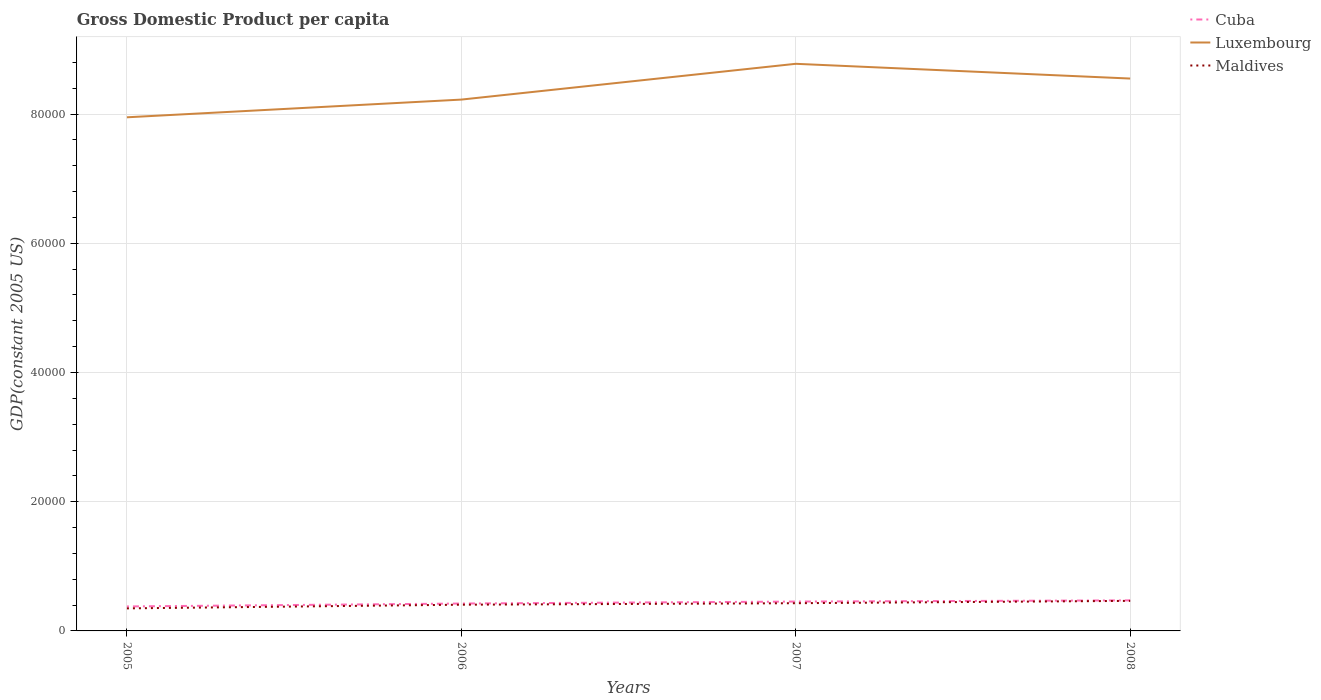How many different coloured lines are there?
Your answer should be very brief. 3. Across all years, what is the maximum GDP per capita in Luxembourg?
Your answer should be very brief. 7.95e+04. In which year was the GDP per capita in Cuba maximum?
Offer a very short reply. 2005. What is the total GDP per capita in Luxembourg in the graph?
Provide a succinct answer. 2281.91. What is the difference between the highest and the second highest GDP per capita in Cuba?
Ensure brevity in your answer.  940.25. What is the difference between the highest and the lowest GDP per capita in Cuba?
Your answer should be compact. 2. Is the GDP per capita in Cuba strictly greater than the GDP per capita in Maldives over the years?
Keep it short and to the point. No. What is the difference between two consecutive major ticks on the Y-axis?
Your answer should be compact. 2.00e+04. Are the values on the major ticks of Y-axis written in scientific E-notation?
Your answer should be very brief. No. Does the graph contain any zero values?
Ensure brevity in your answer.  No. How many legend labels are there?
Your response must be concise. 3. What is the title of the graph?
Keep it short and to the point. Gross Domestic Product per capita. Does "Singapore" appear as one of the legend labels in the graph?
Your answer should be very brief. No. What is the label or title of the X-axis?
Make the answer very short. Years. What is the label or title of the Y-axis?
Provide a succinct answer. GDP(constant 2005 US). What is the GDP(constant 2005 US) of Cuba in 2005?
Keep it short and to the point. 3786.88. What is the GDP(constant 2005 US) in Luxembourg in 2005?
Offer a very short reply. 7.95e+04. What is the GDP(constant 2005 US) of Maldives in 2005?
Ensure brevity in your answer.  3488.49. What is the GDP(constant 2005 US) of Cuba in 2006?
Ensure brevity in your answer.  4238.47. What is the GDP(constant 2005 US) of Luxembourg in 2006?
Offer a terse response. 8.22e+04. What is the GDP(constant 2005 US) of Maldives in 2006?
Offer a very short reply. 4057.34. What is the GDP(constant 2005 US) in Cuba in 2007?
Your response must be concise. 4542.71. What is the GDP(constant 2005 US) in Luxembourg in 2007?
Keep it short and to the point. 8.78e+04. What is the GDP(constant 2005 US) in Maldives in 2007?
Offer a very short reply. 4289.08. What is the GDP(constant 2005 US) of Cuba in 2008?
Offer a terse response. 4727.13. What is the GDP(constant 2005 US) of Luxembourg in 2008?
Your response must be concise. 8.55e+04. What is the GDP(constant 2005 US) in Maldives in 2008?
Offer a terse response. 4650.98. Across all years, what is the maximum GDP(constant 2005 US) in Cuba?
Keep it short and to the point. 4727.13. Across all years, what is the maximum GDP(constant 2005 US) of Luxembourg?
Your response must be concise. 8.78e+04. Across all years, what is the maximum GDP(constant 2005 US) of Maldives?
Your response must be concise. 4650.98. Across all years, what is the minimum GDP(constant 2005 US) of Cuba?
Your answer should be compact. 3786.88. Across all years, what is the minimum GDP(constant 2005 US) in Luxembourg?
Keep it short and to the point. 7.95e+04. Across all years, what is the minimum GDP(constant 2005 US) in Maldives?
Ensure brevity in your answer.  3488.49. What is the total GDP(constant 2005 US) of Cuba in the graph?
Your answer should be compact. 1.73e+04. What is the total GDP(constant 2005 US) in Luxembourg in the graph?
Your response must be concise. 3.35e+05. What is the total GDP(constant 2005 US) in Maldives in the graph?
Provide a short and direct response. 1.65e+04. What is the difference between the GDP(constant 2005 US) in Cuba in 2005 and that in 2006?
Your response must be concise. -451.59. What is the difference between the GDP(constant 2005 US) of Luxembourg in 2005 and that in 2006?
Provide a short and direct response. -2740.42. What is the difference between the GDP(constant 2005 US) of Maldives in 2005 and that in 2006?
Offer a terse response. -568.85. What is the difference between the GDP(constant 2005 US) in Cuba in 2005 and that in 2007?
Provide a short and direct response. -755.83. What is the difference between the GDP(constant 2005 US) in Luxembourg in 2005 and that in 2007?
Make the answer very short. -8278.48. What is the difference between the GDP(constant 2005 US) of Maldives in 2005 and that in 2007?
Keep it short and to the point. -800.59. What is the difference between the GDP(constant 2005 US) of Cuba in 2005 and that in 2008?
Give a very brief answer. -940.25. What is the difference between the GDP(constant 2005 US) of Luxembourg in 2005 and that in 2008?
Keep it short and to the point. -5996.57. What is the difference between the GDP(constant 2005 US) of Maldives in 2005 and that in 2008?
Your answer should be very brief. -1162.48. What is the difference between the GDP(constant 2005 US) in Cuba in 2006 and that in 2007?
Make the answer very short. -304.24. What is the difference between the GDP(constant 2005 US) in Luxembourg in 2006 and that in 2007?
Provide a succinct answer. -5538.06. What is the difference between the GDP(constant 2005 US) in Maldives in 2006 and that in 2007?
Keep it short and to the point. -231.74. What is the difference between the GDP(constant 2005 US) of Cuba in 2006 and that in 2008?
Your answer should be compact. -488.66. What is the difference between the GDP(constant 2005 US) of Luxembourg in 2006 and that in 2008?
Your answer should be compact. -3256.14. What is the difference between the GDP(constant 2005 US) of Maldives in 2006 and that in 2008?
Your answer should be very brief. -593.63. What is the difference between the GDP(constant 2005 US) in Cuba in 2007 and that in 2008?
Provide a short and direct response. -184.42. What is the difference between the GDP(constant 2005 US) in Luxembourg in 2007 and that in 2008?
Keep it short and to the point. 2281.91. What is the difference between the GDP(constant 2005 US) of Maldives in 2007 and that in 2008?
Offer a very short reply. -361.89. What is the difference between the GDP(constant 2005 US) in Cuba in 2005 and the GDP(constant 2005 US) in Luxembourg in 2006?
Your answer should be compact. -7.84e+04. What is the difference between the GDP(constant 2005 US) of Cuba in 2005 and the GDP(constant 2005 US) of Maldives in 2006?
Your response must be concise. -270.47. What is the difference between the GDP(constant 2005 US) of Luxembourg in 2005 and the GDP(constant 2005 US) of Maldives in 2006?
Offer a very short reply. 7.54e+04. What is the difference between the GDP(constant 2005 US) in Cuba in 2005 and the GDP(constant 2005 US) in Luxembourg in 2007?
Provide a short and direct response. -8.40e+04. What is the difference between the GDP(constant 2005 US) of Cuba in 2005 and the GDP(constant 2005 US) of Maldives in 2007?
Your response must be concise. -502.21. What is the difference between the GDP(constant 2005 US) in Luxembourg in 2005 and the GDP(constant 2005 US) in Maldives in 2007?
Your response must be concise. 7.52e+04. What is the difference between the GDP(constant 2005 US) of Cuba in 2005 and the GDP(constant 2005 US) of Luxembourg in 2008?
Your response must be concise. -8.17e+04. What is the difference between the GDP(constant 2005 US) in Cuba in 2005 and the GDP(constant 2005 US) in Maldives in 2008?
Give a very brief answer. -864.1. What is the difference between the GDP(constant 2005 US) of Luxembourg in 2005 and the GDP(constant 2005 US) of Maldives in 2008?
Give a very brief answer. 7.48e+04. What is the difference between the GDP(constant 2005 US) of Cuba in 2006 and the GDP(constant 2005 US) of Luxembourg in 2007?
Give a very brief answer. -8.35e+04. What is the difference between the GDP(constant 2005 US) of Cuba in 2006 and the GDP(constant 2005 US) of Maldives in 2007?
Offer a very short reply. -50.62. What is the difference between the GDP(constant 2005 US) in Luxembourg in 2006 and the GDP(constant 2005 US) in Maldives in 2007?
Your answer should be compact. 7.79e+04. What is the difference between the GDP(constant 2005 US) of Cuba in 2006 and the GDP(constant 2005 US) of Luxembourg in 2008?
Give a very brief answer. -8.13e+04. What is the difference between the GDP(constant 2005 US) in Cuba in 2006 and the GDP(constant 2005 US) in Maldives in 2008?
Your response must be concise. -412.51. What is the difference between the GDP(constant 2005 US) in Luxembourg in 2006 and the GDP(constant 2005 US) in Maldives in 2008?
Ensure brevity in your answer.  7.76e+04. What is the difference between the GDP(constant 2005 US) of Cuba in 2007 and the GDP(constant 2005 US) of Luxembourg in 2008?
Your answer should be compact. -8.09e+04. What is the difference between the GDP(constant 2005 US) of Cuba in 2007 and the GDP(constant 2005 US) of Maldives in 2008?
Offer a very short reply. -108.27. What is the difference between the GDP(constant 2005 US) in Luxembourg in 2007 and the GDP(constant 2005 US) in Maldives in 2008?
Offer a terse response. 8.31e+04. What is the average GDP(constant 2005 US) in Cuba per year?
Your response must be concise. 4323.79. What is the average GDP(constant 2005 US) of Luxembourg per year?
Offer a terse response. 8.37e+04. What is the average GDP(constant 2005 US) of Maldives per year?
Keep it short and to the point. 4121.47. In the year 2005, what is the difference between the GDP(constant 2005 US) of Cuba and GDP(constant 2005 US) of Luxembourg?
Your answer should be compact. -7.57e+04. In the year 2005, what is the difference between the GDP(constant 2005 US) of Cuba and GDP(constant 2005 US) of Maldives?
Provide a short and direct response. 298.38. In the year 2005, what is the difference between the GDP(constant 2005 US) of Luxembourg and GDP(constant 2005 US) of Maldives?
Your response must be concise. 7.60e+04. In the year 2006, what is the difference between the GDP(constant 2005 US) of Cuba and GDP(constant 2005 US) of Luxembourg?
Your answer should be compact. -7.80e+04. In the year 2006, what is the difference between the GDP(constant 2005 US) of Cuba and GDP(constant 2005 US) of Maldives?
Offer a terse response. 181.13. In the year 2006, what is the difference between the GDP(constant 2005 US) of Luxembourg and GDP(constant 2005 US) of Maldives?
Provide a succinct answer. 7.82e+04. In the year 2007, what is the difference between the GDP(constant 2005 US) in Cuba and GDP(constant 2005 US) in Luxembourg?
Your answer should be compact. -8.32e+04. In the year 2007, what is the difference between the GDP(constant 2005 US) in Cuba and GDP(constant 2005 US) in Maldives?
Provide a short and direct response. 253.62. In the year 2007, what is the difference between the GDP(constant 2005 US) of Luxembourg and GDP(constant 2005 US) of Maldives?
Provide a succinct answer. 8.35e+04. In the year 2008, what is the difference between the GDP(constant 2005 US) of Cuba and GDP(constant 2005 US) of Luxembourg?
Provide a short and direct response. -8.08e+04. In the year 2008, what is the difference between the GDP(constant 2005 US) in Cuba and GDP(constant 2005 US) in Maldives?
Provide a short and direct response. 76.15. In the year 2008, what is the difference between the GDP(constant 2005 US) of Luxembourg and GDP(constant 2005 US) of Maldives?
Make the answer very short. 8.08e+04. What is the ratio of the GDP(constant 2005 US) in Cuba in 2005 to that in 2006?
Provide a short and direct response. 0.89. What is the ratio of the GDP(constant 2005 US) in Luxembourg in 2005 to that in 2006?
Provide a short and direct response. 0.97. What is the ratio of the GDP(constant 2005 US) of Maldives in 2005 to that in 2006?
Give a very brief answer. 0.86. What is the ratio of the GDP(constant 2005 US) in Cuba in 2005 to that in 2007?
Your response must be concise. 0.83. What is the ratio of the GDP(constant 2005 US) in Luxembourg in 2005 to that in 2007?
Your response must be concise. 0.91. What is the ratio of the GDP(constant 2005 US) in Maldives in 2005 to that in 2007?
Provide a succinct answer. 0.81. What is the ratio of the GDP(constant 2005 US) of Cuba in 2005 to that in 2008?
Provide a short and direct response. 0.8. What is the ratio of the GDP(constant 2005 US) of Luxembourg in 2005 to that in 2008?
Make the answer very short. 0.93. What is the ratio of the GDP(constant 2005 US) of Maldives in 2005 to that in 2008?
Your answer should be compact. 0.75. What is the ratio of the GDP(constant 2005 US) of Cuba in 2006 to that in 2007?
Ensure brevity in your answer.  0.93. What is the ratio of the GDP(constant 2005 US) of Luxembourg in 2006 to that in 2007?
Your answer should be very brief. 0.94. What is the ratio of the GDP(constant 2005 US) of Maldives in 2006 to that in 2007?
Your answer should be very brief. 0.95. What is the ratio of the GDP(constant 2005 US) in Cuba in 2006 to that in 2008?
Ensure brevity in your answer.  0.9. What is the ratio of the GDP(constant 2005 US) in Luxembourg in 2006 to that in 2008?
Ensure brevity in your answer.  0.96. What is the ratio of the GDP(constant 2005 US) of Maldives in 2006 to that in 2008?
Your answer should be compact. 0.87. What is the ratio of the GDP(constant 2005 US) in Luxembourg in 2007 to that in 2008?
Offer a terse response. 1.03. What is the ratio of the GDP(constant 2005 US) of Maldives in 2007 to that in 2008?
Your answer should be compact. 0.92. What is the difference between the highest and the second highest GDP(constant 2005 US) of Cuba?
Provide a short and direct response. 184.42. What is the difference between the highest and the second highest GDP(constant 2005 US) in Luxembourg?
Make the answer very short. 2281.91. What is the difference between the highest and the second highest GDP(constant 2005 US) in Maldives?
Keep it short and to the point. 361.89. What is the difference between the highest and the lowest GDP(constant 2005 US) in Cuba?
Your response must be concise. 940.25. What is the difference between the highest and the lowest GDP(constant 2005 US) in Luxembourg?
Keep it short and to the point. 8278.48. What is the difference between the highest and the lowest GDP(constant 2005 US) in Maldives?
Keep it short and to the point. 1162.48. 